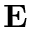Convert formula to latex. <formula><loc_0><loc_0><loc_500><loc_500>E</formula> 